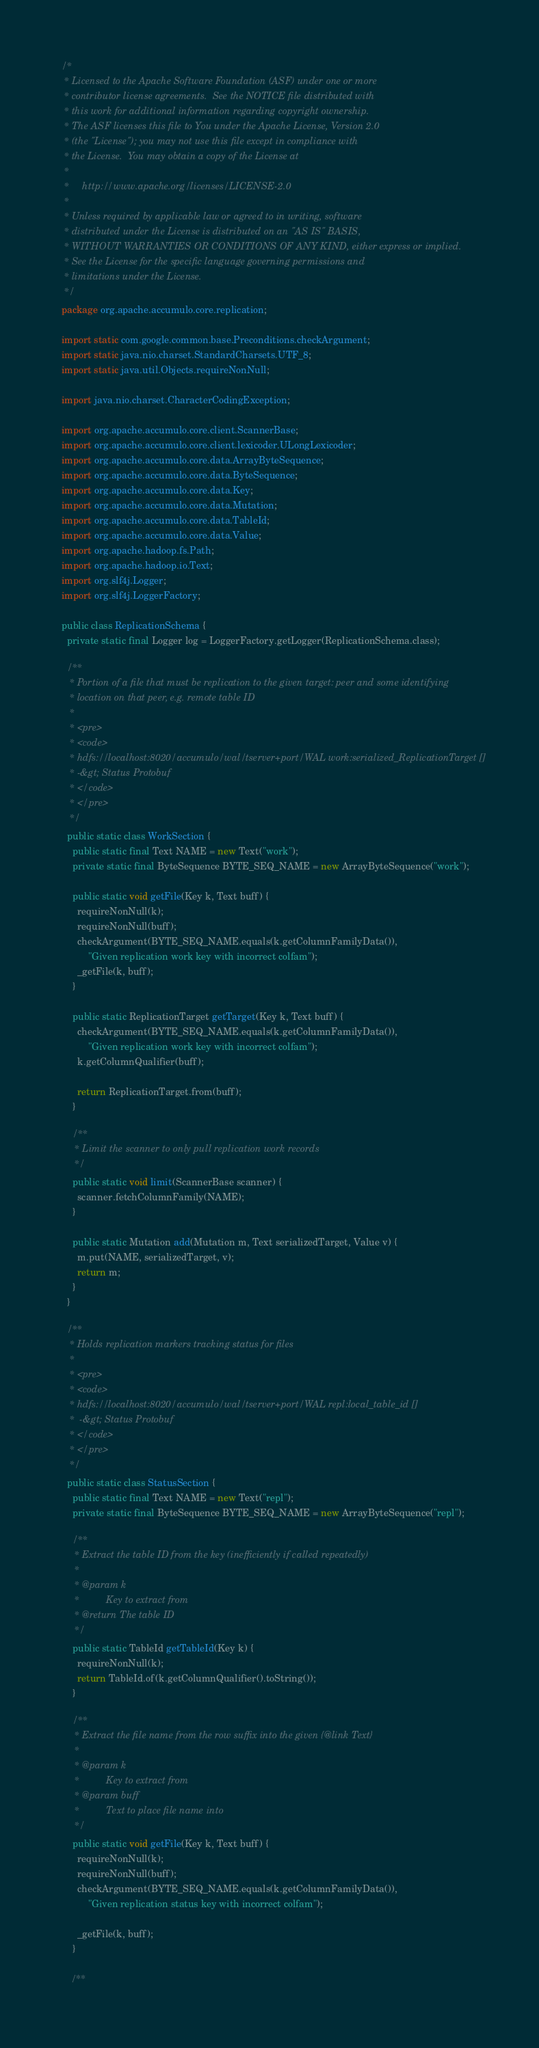<code> <loc_0><loc_0><loc_500><loc_500><_Java_>/*
 * Licensed to the Apache Software Foundation (ASF) under one or more
 * contributor license agreements.  See the NOTICE file distributed with
 * this work for additional information regarding copyright ownership.
 * The ASF licenses this file to You under the Apache License, Version 2.0
 * (the "License"); you may not use this file except in compliance with
 * the License.  You may obtain a copy of the License at
 *
 *     http://www.apache.org/licenses/LICENSE-2.0
 *
 * Unless required by applicable law or agreed to in writing, software
 * distributed under the License is distributed on an "AS IS" BASIS,
 * WITHOUT WARRANTIES OR CONDITIONS OF ANY KIND, either express or implied.
 * See the License for the specific language governing permissions and
 * limitations under the License.
 */
package org.apache.accumulo.core.replication;

import static com.google.common.base.Preconditions.checkArgument;
import static java.nio.charset.StandardCharsets.UTF_8;
import static java.util.Objects.requireNonNull;

import java.nio.charset.CharacterCodingException;

import org.apache.accumulo.core.client.ScannerBase;
import org.apache.accumulo.core.client.lexicoder.ULongLexicoder;
import org.apache.accumulo.core.data.ArrayByteSequence;
import org.apache.accumulo.core.data.ByteSequence;
import org.apache.accumulo.core.data.Key;
import org.apache.accumulo.core.data.Mutation;
import org.apache.accumulo.core.data.TableId;
import org.apache.accumulo.core.data.Value;
import org.apache.hadoop.fs.Path;
import org.apache.hadoop.io.Text;
import org.slf4j.Logger;
import org.slf4j.LoggerFactory;

public class ReplicationSchema {
  private static final Logger log = LoggerFactory.getLogger(ReplicationSchema.class);

  /**
   * Portion of a file that must be replication to the given target: peer and some identifying
   * location on that peer, e.g. remote table ID
   *
   * <pre>
   * <code>
   * hdfs://localhost:8020/accumulo/wal/tserver+port/WAL work:serialized_ReplicationTarget []
   * -&gt; Status Protobuf
   * </code>
   * </pre>
   */
  public static class WorkSection {
    public static final Text NAME = new Text("work");
    private static final ByteSequence BYTE_SEQ_NAME = new ArrayByteSequence("work");

    public static void getFile(Key k, Text buff) {
      requireNonNull(k);
      requireNonNull(buff);
      checkArgument(BYTE_SEQ_NAME.equals(k.getColumnFamilyData()),
          "Given replication work key with incorrect colfam");
      _getFile(k, buff);
    }

    public static ReplicationTarget getTarget(Key k, Text buff) {
      checkArgument(BYTE_SEQ_NAME.equals(k.getColumnFamilyData()),
          "Given replication work key with incorrect colfam");
      k.getColumnQualifier(buff);

      return ReplicationTarget.from(buff);
    }

    /**
     * Limit the scanner to only pull replication work records
     */
    public static void limit(ScannerBase scanner) {
      scanner.fetchColumnFamily(NAME);
    }

    public static Mutation add(Mutation m, Text serializedTarget, Value v) {
      m.put(NAME, serializedTarget, v);
      return m;
    }
  }

  /**
   * Holds replication markers tracking status for files
   *
   * <pre>
   * <code>
   * hdfs://localhost:8020/accumulo/wal/tserver+port/WAL repl:local_table_id []
   *  -&gt; Status Protobuf
   * </code>
   * </pre>
   */
  public static class StatusSection {
    public static final Text NAME = new Text("repl");
    private static final ByteSequence BYTE_SEQ_NAME = new ArrayByteSequence("repl");

    /**
     * Extract the table ID from the key (inefficiently if called repeatedly)
     *
     * @param k
     *          Key to extract from
     * @return The table ID
     */
    public static TableId getTableId(Key k) {
      requireNonNull(k);
      return TableId.of(k.getColumnQualifier().toString());
    }

    /**
     * Extract the file name from the row suffix into the given {@link Text}
     *
     * @param k
     *          Key to extract from
     * @param buff
     *          Text to place file name into
     */
    public static void getFile(Key k, Text buff) {
      requireNonNull(k);
      requireNonNull(buff);
      checkArgument(BYTE_SEQ_NAME.equals(k.getColumnFamilyData()),
          "Given replication status key with incorrect colfam");

      _getFile(k, buff);
    }

    /**</code> 